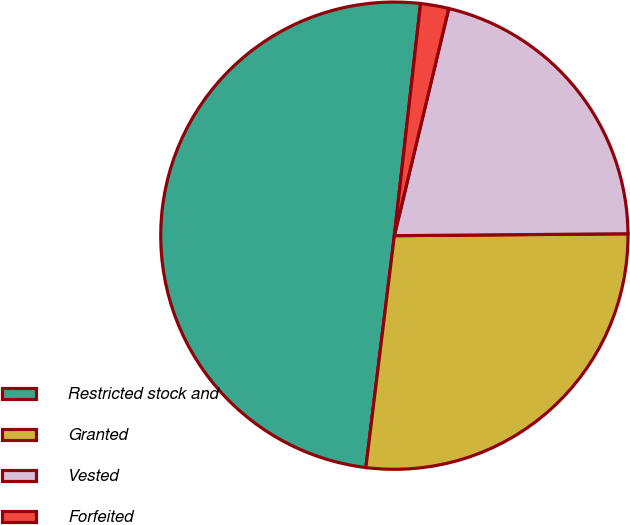Convert chart to OTSL. <chart><loc_0><loc_0><loc_500><loc_500><pie_chart><fcel>Restricted stock and<fcel>Granted<fcel>Vested<fcel>Forfeited<nl><fcel>49.85%<fcel>27.08%<fcel>21.13%<fcel>1.95%<nl></chart> 